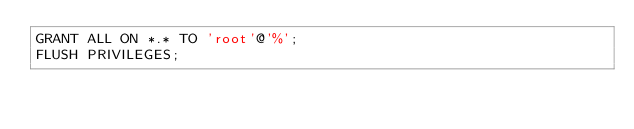Convert code to text. <code><loc_0><loc_0><loc_500><loc_500><_SQL_>GRANT ALL ON *.* TO 'root'@'%';
FLUSH PRIVILEGES;
</code> 